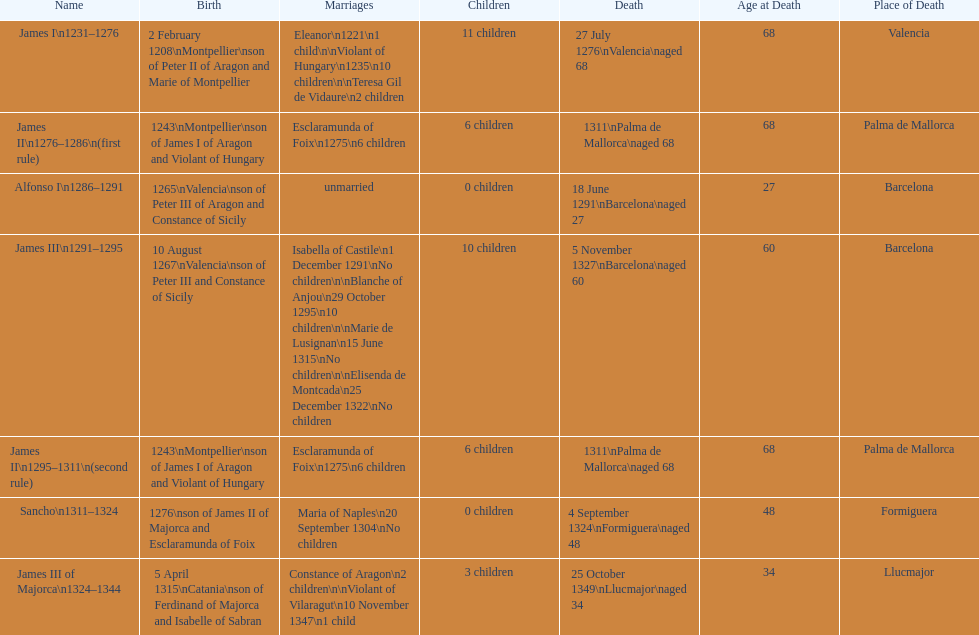How many of these monarchs died before the age of 65? 4. 